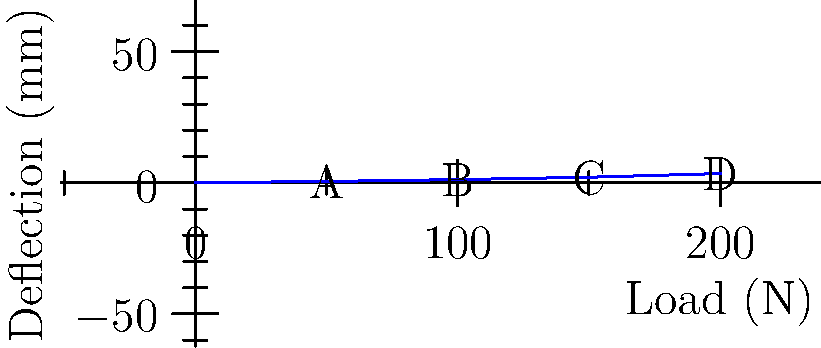A structural engineer is analyzing the load-deflection characteristics of a briefcase. The graph shows the relationship between applied load and deflection. If the maximum allowable deflection is 2.5 mm, what is the maximum load the briefcase can safely carry? To solve this problem, we need to follow these steps:

1. Understand the given information:
   - The graph shows the load-deflection relationship for the briefcase.
   - The maximum allowable deflection is 2.5 mm.

2. Analyze the graph:
   - The x-axis represents the load in Newtons (N).
   - The y-axis represents the deflection in millimeters (mm).
   - The graph shows four points: A(50, 0.5), B(100, 1.2), C(150, 2.1), and D(200, 3.5).

3. Identify the relevant data points:
   - We need to find the load that corresponds to a deflection of 2.5 mm.
   - This point lies between points C(150, 2.1) and D(200, 3.5).

4. Interpolate between the two closest points:
   - Use the linear interpolation formula:
     $$y = y_1 + \frac{(x - x_1)(y_2 - y_1)}{(x_2 - x_1)}$$
   - Where (x_1, y_1) is (150, 2.1) and (x_2, y_2) is (200, 3.5)
   - Substitute the known values:
     $$2.5 = 2.1 + \frac{(x - 150)(3.5 - 2.1)}{(200 - 150)}$$

5. Solve for x (the load):
   $$2.5 = 2.1 + \frac{(x - 150)(1.4)}{50}$$
   $$0.4 = \frac{(x - 150)(1.4)}{50}$$
   $$14.29 = x - 150$$
   $$x = 164.29$$

6. Round the result to a practical precision:
   The maximum load is approximately 164 N.
Answer: 164 N 